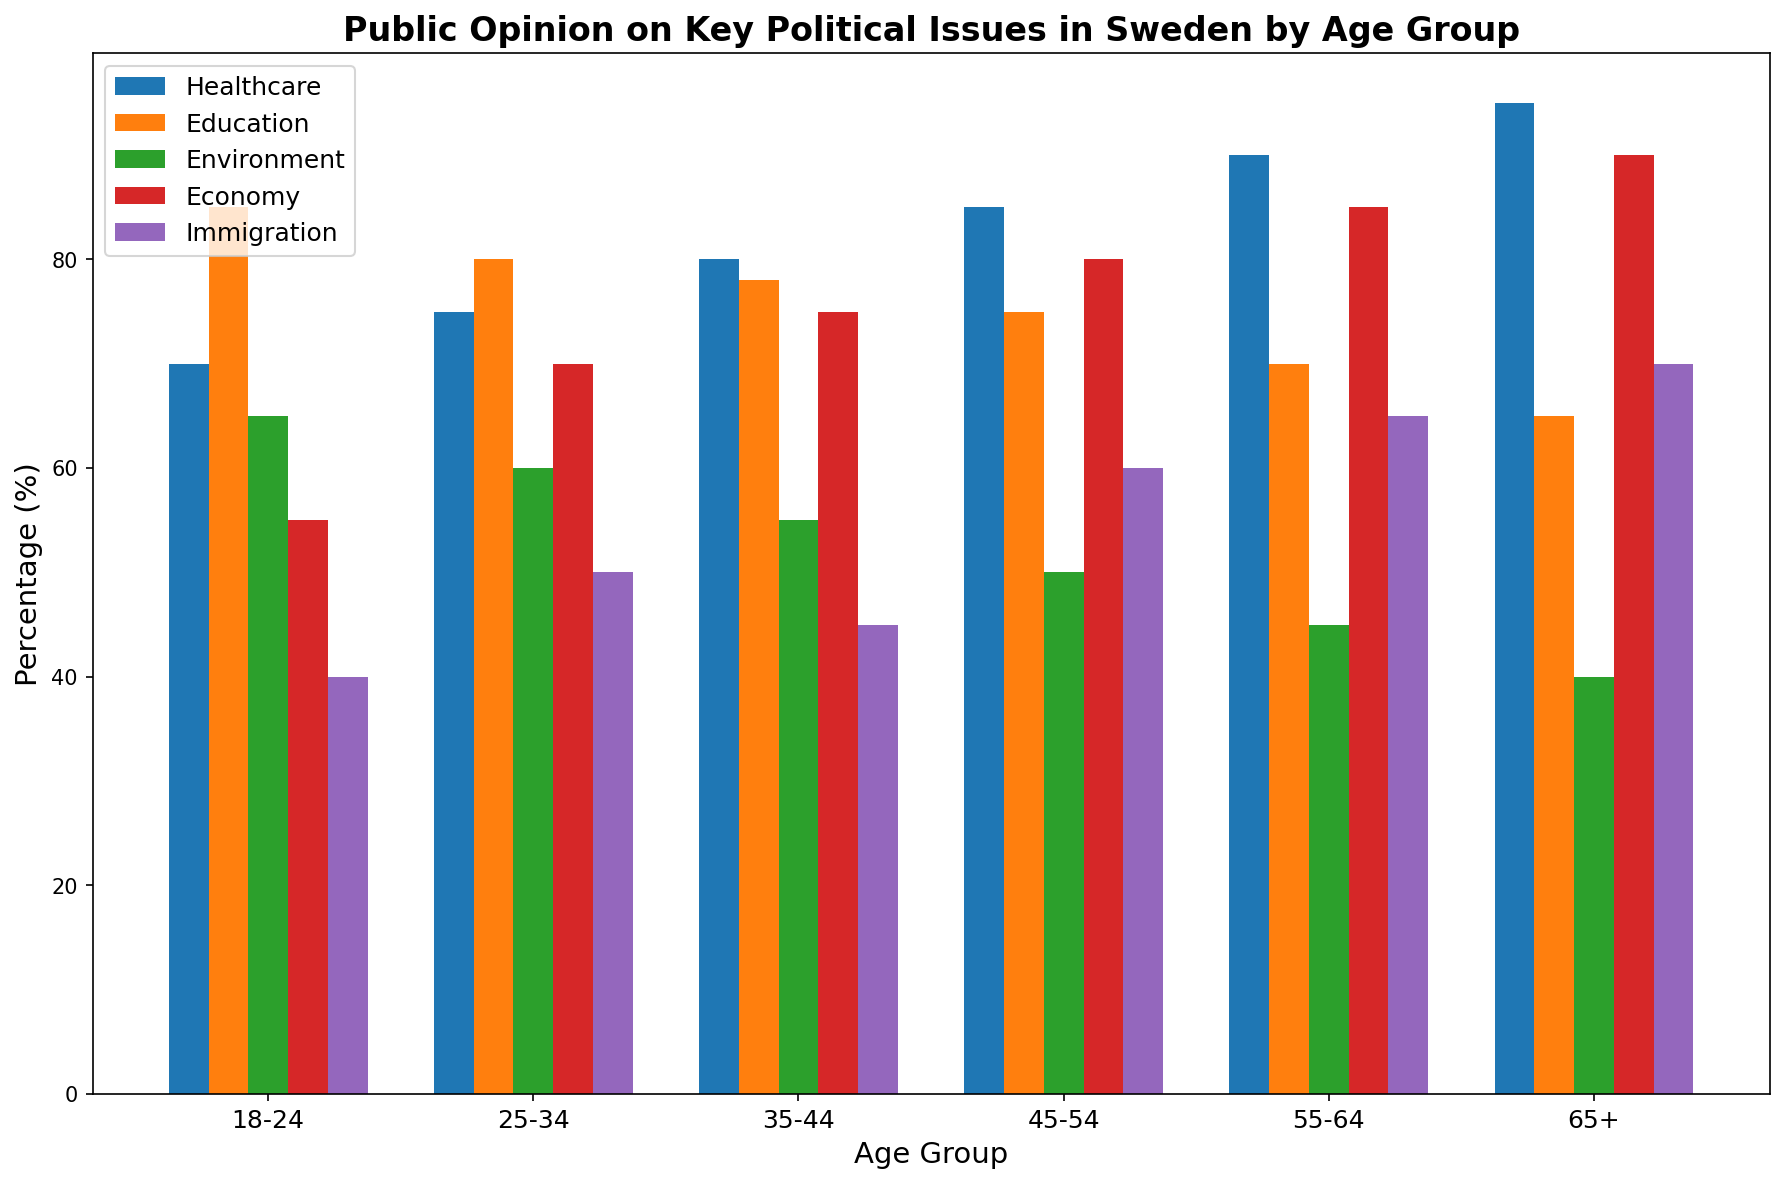Which age group prioritizes Healthcare the most? We look for the highest bar in the Healthcare category. The bar for the 65+ age group is the tallest, indicating the highest percentage for Healthcare.
Answer: 65+ Which issue is least important to the 18-24 age group? For the 18-24 age group, check the bars representing each issue. The Immigration bar is the shortest, indicating the lowest percentage.
Answer: Immigration Compare the importance of Education between the 25-34 and 35-44 age groups. Which group considers it more important? Observe the Education bars for both the 25-34 and 35-44 age groups. The bar for 25-34 is slightly higher, indicating a higher percentage.
Answer: 25-34 Which issue sees the most consistent level of importance across all age groups? Observe the bars for each issue across all age groups and look for the least variation in height. The Healthcare bars are relatively consistent, indicating similar importance levels across age groups.
Answer: Healthcare In the 55-64 age group, what is the difference in importance between the Economy and Environment issues? Check the heights of the Economy and Environment bars for the 55-64 age group. Economy is at 85%, and Environment is at 45%. The difference is 85% - 45% = 40%.
Answer: 40% How does the importance of Immigration change between the 45-54 and 65+ age groups? Observe the bars for Immigration in the 45-54 and 65+ age groups. The bar for 65+ is taller. To find the change: 70% (65+) - 60% (45-54) = 10%.
Answer: Increases by 10% Which age group shows the greatest concern for the Environment? Identify which age group has the tallest bar in the Environment category. The 18-24 age group’s bar is the tallest.
Answer: 18-24 What's the average importance of Economy across all age groups? Sum the percentages for Economy across all age groups and divide by the number of age groups. (55%+70%+75%+80%+85%+90%) / 6 = 75.83%.
Answer: 75.83% Is Education more important to the 55-64 or 18-24 age group? Compare the Education bars for the 55-64 and 18-24 age groups. The 18-24 group's bar is taller.
Answer: 18-24 Which issue has the lowest average importance across all age groups? Calculate the average percentage for each issue and identify the lowest. Immigration: (40%+50%+45%+60%+65%+70%) / 6 = 55%
Answer: Immigration 